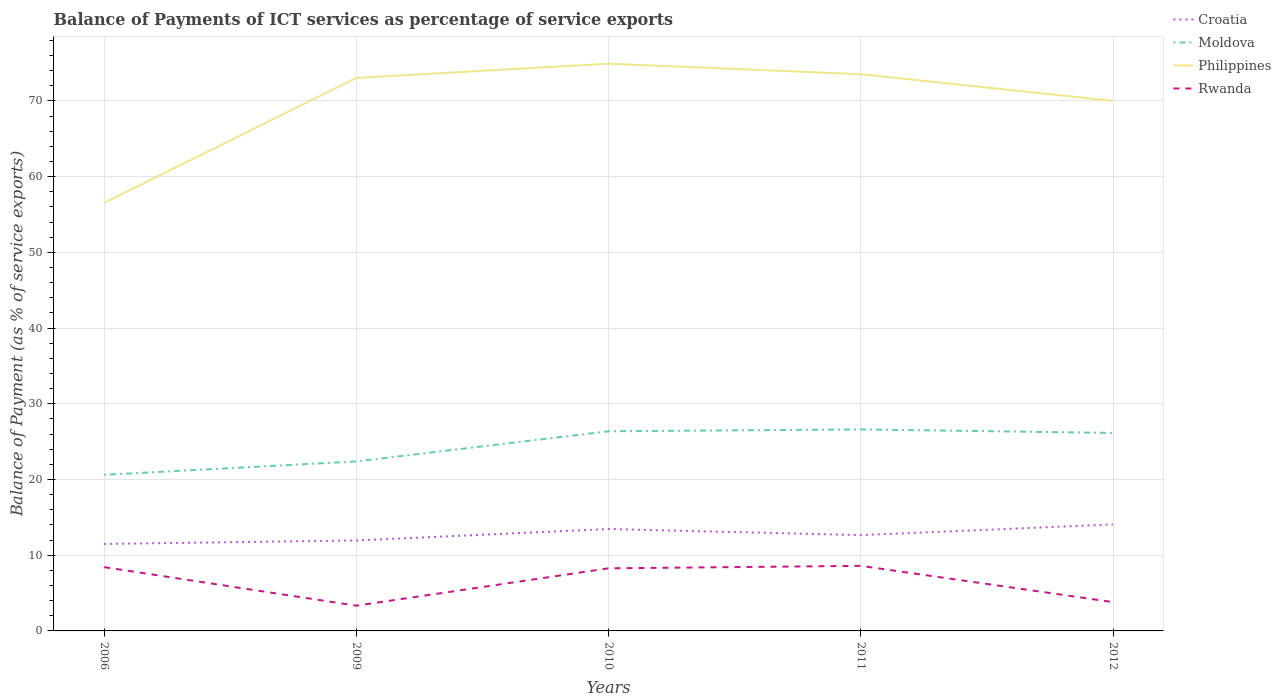Across all years, what is the maximum balance of payments of ICT services in Moldova?
Keep it short and to the point. 20.62. What is the total balance of payments of ICT services in Philippines in the graph?
Give a very brief answer. -18.39. What is the difference between the highest and the second highest balance of payments of ICT services in Croatia?
Give a very brief answer. 2.57. Is the balance of payments of ICT services in Philippines strictly greater than the balance of payments of ICT services in Croatia over the years?
Your response must be concise. No. How many years are there in the graph?
Give a very brief answer. 5. Are the values on the major ticks of Y-axis written in scientific E-notation?
Offer a very short reply. No. Does the graph contain any zero values?
Ensure brevity in your answer.  No. How are the legend labels stacked?
Provide a short and direct response. Vertical. What is the title of the graph?
Your response must be concise. Balance of Payments of ICT services as percentage of service exports. Does "Cote d'Ivoire" appear as one of the legend labels in the graph?
Your answer should be very brief. No. What is the label or title of the Y-axis?
Make the answer very short. Balance of Payment (as % of service exports). What is the Balance of Payment (as % of service exports) of Croatia in 2006?
Offer a terse response. 11.49. What is the Balance of Payment (as % of service exports) of Moldova in 2006?
Your response must be concise. 20.62. What is the Balance of Payment (as % of service exports) of Philippines in 2006?
Your answer should be compact. 56.53. What is the Balance of Payment (as % of service exports) in Rwanda in 2006?
Provide a succinct answer. 8.42. What is the Balance of Payment (as % of service exports) in Croatia in 2009?
Offer a terse response. 11.94. What is the Balance of Payment (as % of service exports) of Moldova in 2009?
Offer a very short reply. 22.39. What is the Balance of Payment (as % of service exports) of Philippines in 2009?
Keep it short and to the point. 73.04. What is the Balance of Payment (as % of service exports) of Rwanda in 2009?
Offer a terse response. 3.33. What is the Balance of Payment (as % of service exports) in Croatia in 2010?
Give a very brief answer. 13.46. What is the Balance of Payment (as % of service exports) of Moldova in 2010?
Provide a short and direct response. 26.37. What is the Balance of Payment (as % of service exports) in Philippines in 2010?
Your answer should be very brief. 74.92. What is the Balance of Payment (as % of service exports) of Rwanda in 2010?
Ensure brevity in your answer.  8.27. What is the Balance of Payment (as % of service exports) of Croatia in 2011?
Give a very brief answer. 12.66. What is the Balance of Payment (as % of service exports) of Moldova in 2011?
Your answer should be very brief. 26.62. What is the Balance of Payment (as % of service exports) in Philippines in 2011?
Provide a short and direct response. 73.53. What is the Balance of Payment (as % of service exports) in Rwanda in 2011?
Make the answer very short. 8.59. What is the Balance of Payment (as % of service exports) in Croatia in 2012?
Your answer should be very brief. 14.06. What is the Balance of Payment (as % of service exports) in Moldova in 2012?
Provide a succinct answer. 26.15. What is the Balance of Payment (as % of service exports) of Philippines in 2012?
Offer a terse response. 70.01. What is the Balance of Payment (as % of service exports) of Rwanda in 2012?
Your answer should be very brief. 3.81. Across all years, what is the maximum Balance of Payment (as % of service exports) in Croatia?
Your answer should be very brief. 14.06. Across all years, what is the maximum Balance of Payment (as % of service exports) in Moldova?
Give a very brief answer. 26.62. Across all years, what is the maximum Balance of Payment (as % of service exports) in Philippines?
Keep it short and to the point. 74.92. Across all years, what is the maximum Balance of Payment (as % of service exports) of Rwanda?
Provide a short and direct response. 8.59. Across all years, what is the minimum Balance of Payment (as % of service exports) in Croatia?
Ensure brevity in your answer.  11.49. Across all years, what is the minimum Balance of Payment (as % of service exports) in Moldova?
Make the answer very short. 20.62. Across all years, what is the minimum Balance of Payment (as % of service exports) of Philippines?
Your answer should be compact. 56.53. Across all years, what is the minimum Balance of Payment (as % of service exports) in Rwanda?
Ensure brevity in your answer.  3.33. What is the total Balance of Payment (as % of service exports) of Croatia in the graph?
Provide a succinct answer. 63.62. What is the total Balance of Payment (as % of service exports) in Moldova in the graph?
Keep it short and to the point. 122.14. What is the total Balance of Payment (as % of service exports) in Philippines in the graph?
Make the answer very short. 348.04. What is the total Balance of Payment (as % of service exports) in Rwanda in the graph?
Offer a very short reply. 32.43. What is the difference between the Balance of Payment (as % of service exports) of Croatia in 2006 and that in 2009?
Provide a short and direct response. -0.45. What is the difference between the Balance of Payment (as % of service exports) of Moldova in 2006 and that in 2009?
Offer a very short reply. -1.77. What is the difference between the Balance of Payment (as % of service exports) of Philippines in 2006 and that in 2009?
Give a very brief answer. -16.51. What is the difference between the Balance of Payment (as % of service exports) in Rwanda in 2006 and that in 2009?
Make the answer very short. 5.09. What is the difference between the Balance of Payment (as % of service exports) of Croatia in 2006 and that in 2010?
Ensure brevity in your answer.  -1.97. What is the difference between the Balance of Payment (as % of service exports) in Moldova in 2006 and that in 2010?
Offer a terse response. -5.75. What is the difference between the Balance of Payment (as % of service exports) in Philippines in 2006 and that in 2010?
Offer a very short reply. -18.39. What is the difference between the Balance of Payment (as % of service exports) in Rwanda in 2006 and that in 2010?
Offer a very short reply. 0.16. What is the difference between the Balance of Payment (as % of service exports) of Croatia in 2006 and that in 2011?
Provide a succinct answer. -1.16. What is the difference between the Balance of Payment (as % of service exports) of Moldova in 2006 and that in 2011?
Your answer should be compact. -6. What is the difference between the Balance of Payment (as % of service exports) of Philippines in 2006 and that in 2011?
Your answer should be very brief. -17. What is the difference between the Balance of Payment (as % of service exports) of Rwanda in 2006 and that in 2011?
Your response must be concise. -0.17. What is the difference between the Balance of Payment (as % of service exports) in Croatia in 2006 and that in 2012?
Your response must be concise. -2.57. What is the difference between the Balance of Payment (as % of service exports) in Moldova in 2006 and that in 2012?
Provide a succinct answer. -5.53. What is the difference between the Balance of Payment (as % of service exports) in Philippines in 2006 and that in 2012?
Your answer should be very brief. -13.47. What is the difference between the Balance of Payment (as % of service exports) of Rwanda in 2006 and that in 2012?
Keep it short and to the point. 4.62. What is the difference between the Balance of Payment (as % of service exports) of Croatia in 2009 and that in 2010?
Provide a succinct answer. -1.52. What is the difference between the Balance of Payment (as % of service exports) in Moldova in 2009 and that in 2010?
Offer a very short reply. -3.98. What is the difference between the Balance of Payment (as % of service exports) in Philippines in 2009 and that in 2010?
Offer a very short reply. -1.88. What is the difference between the Balance of Payment (as % of service exports) of Rwanda in 2009 and that in 2010?
Offer a terse response. -4.93. What is the difference between the Balance of Payment (as % of service exports) of Croatia in 2009 and that in 2011?
Your answer should be very brief. -0.71. What is the difference between the Balance of Payment (as % of service exports) of Moldova in 2009 and that in 2011?
Provide a succinct answer. -4.23. What is the difference between the Balance of Payment (as % of service exports) of Philippines in 2009 and that in 2011?
Provide a short and direct response. -0.49. What is the difference between the Balance of Payment (as % of service exports) in Rwanda in 2009 and that in 2011?
Your answer should be compact. -5.26. What is the difference between the Balance of Payment (as % of service exports) in Croatia in 2009 and that in 2012?
Your answer should be compact. -2.12. What is the difference between the Balance of Payment (as % of service exports) of Moldova in 2009 and that in 2012?
Your response must be concise. -3.76. What is the difference between the Balance of Payment (as % of service exports) in Philippines in 2009 and that in 2012?
Provide a succinct answer. 3.03. What is the difference between the Balance of Payment (as % of service exports) in Rwanda in 2009 and that in 2012?
Offer a very short reply. -0.47. What is the difference between the Balance of Payment (as % of service exports) of Croatia in 2010 and that in 2011?
Provide a succinct answer. 0.81. What is the difference between the Balance of Payment (as % of service exports) in Moldova in 2010 and that in 2011?
Offer a very short reply. -0.25. What is the difference between the Balance of Payment (as % of service exports) of Philippines in 2010 and that in 2011?
Offer a very short reply. 1.39. What is the difference between the Balance of Payment (as % of service exports) of Rwanda in 2010 and that in 2011?
Provide a succinct answer. -0.33. What is the difference between the Balance of Payment (as % of service exports) of Croatia in 2010 and that in 2012?
Make the answer very short. -0.6. What is the difference between the Balance of Payment (as % of service exports) in Moldova in 2010 and that in 2012?
Offer a terse response. 0.22. What is the difference between the Balance of Payment (as % of service exports) in Philippines in 2010 and that in 2012?
Your answer should be very brief. 4.92. What is the difference between the Balance of Payment (as % of service exports) in Rwanda in 2010 and that in 2012?
Provide a short and direct response. 4.46. What is the difference between the Balance of Payment (as % of service exports) in Croatia in 2011 and that in 2012?
Give a very brief answer. -1.41. What is the difference between the Balance of Payment (as % of service exports) in Moldova in 2011 and that in 2012?
Ensure brevity in your answer.  0.47. What is the difference between the Balance of Payment (as % of service exports) in Philippines in 2011 and that in 2012?
Give a very brief answer. 3.53. What is the difference between the Balance of Payment (as % of service exports) in Rwanda in 2011 and that in 2012?
Your response must be concise. 4.79. What is the difference between the Balance of Payment (as % of service exports) in Croatia in 2006 and the Balance of Payment (as % of service exports) in Moldova in 2009?
Offer a terse response. -10.9. What is the difference between the Balance of Payment (as % of service exports) in Croatia in 2006 and the Balance of Payment (as % of service exports) in Philippines in 2009?
Provide a short and direct response. -61.55. What is the difference between the Balance of Payment (as % of service exports) of Croatia in 2006 and the Balance of Payment (as % of service exports) of Rwanda in 2009?
Give a very brief answer. 8.16. What is the difference between the Balance of Payment (as % of service exports) of Moldova in 2006 and the Balance of Payment (as % of service exports) of Philippines in 2009?
Ensure brevity in your answer.  -52.42. What is the difference between the Balance of Payment (as % of service exports) in Moldova in 2006 and the Balance of Payment (as % of service exports) in Rwanda in 2009?
Provide a short and direct response. 17.28. What is the difference between the Balance of Payment (as % of service exports) of Philippines in 2006 and the Balance of Payment (as % of service exports) of Rwanda in 2009?
Offer a terse response. 53.2. What is the difference between the Balance of Payment (as % of service exports) in Croatia in 2006 and the Balance of Payment (as % of service exports) in Moldova in 2010?
Keep it short and to the point. -14.88. What is the difference between the Balance of Payment (as % of service exports) of Croatia in 2006 and the Balance of Payment (as % of service exports) of Philippines in 2010?
Provide a short and direct response. -63.43. What is the difference between the Balance of Payment (as % of service exports) of Croatia in 2006 and the Balance of Payment (as % of service exports) of Rwanda in 2010?
Keep it short and to the point. 3.22. What is the difference between the Balance of Payment (as % of service exports) of Moldova in 2006 and the Balance of Payment (as % of service exports) of Philippines in 2010?
Your answer should be very brief. -54.3. What is the difference between the Balance of Payment (as % of service exports) of Moldova in 2006 and the Balance of Payment (as % of service exports) of Rwanda in 2010?
Provide a short and direct response. 12.35. What is the difference between the Balance of Payment (as % of service exports) in Philippines in 2006 and the Balance of Payment (as % of service exports) in Rwanda in 2010?
Your answer should be very brief. 48.27. What is the difference between the Balance of Payment (as % of service exports) of Croatia in 2006 and the Balance of Payment (as % of service exports) of Moldova in 2011?
Ensure brevity in your answer.  -15.13. What is the difference between the Balance of Payment (as % of service exports) in Croatia in 2006 and the Balance of Payment (as % of service exports) in Philippines in 2011?
Ensure brevity in your answer.  -62.04. What is the difference between the Balance of Payment (as % of service exports) of Croatia in 2006 and the Balance of Payment (as % of service exports) of Rwanda in 2011?
Your answer should be compact. 2.9. What is the difference between the Balance of Payment (as % of service exports) of Moldova in 2006 and the Balance of Payment (as % of service exports) of Philippines in 2011?
Offer a very short reply. -52.91. What is the difference between the Balance of Payment (as % of service exports) of Moldova in 2006 and the Balance of Payment (as % of service exports) of Rwanda in 2011?
Offer a very short reply. 12.02. What is the difference between the Balance of Payment (as % of service exports) in Philippines in 2006 and the Balance of Payment (as % of service exports) in Rwanda in 2011?
Your answer should be compact. 47.94. What is the difference between the Balance of Payment (as % of service exports) in Croatia in 2006 and the Balance of Payment (as % of service exports) in Moldova in 2012?
Make the answer very short. -14.66. What is the difference between the Balance of Payment (as % of service exports) of Croatia in 2006 and the Balance of Payment (as % of service exports) of Philippines in 2012?
Keep it short and to the point. -58.52. What is the difference between the Balance of Payment (as % of service exports) of Croatia in 2006 and the Balance of Payment (as % of service exports) of Rwanda in 2012?
Give a very brief answer. 7.68. What is the difference between the Balance of Payment (as % of service exports) of Moldova in 2006 and the Balance of Payment (as % of service exports) of Philippines in 2012?
Ensure brevity in your answer.  -49.39. What is the difference between the Balance of Payment (as % of service exports) in Moldova in 2006 and the Balance of Payment (as % of service exports) in Rwanda in 2012?
Offer a very short reply. 16.81. What is the difference between the Balance of Payment (as % of service exports) in Philippines in 2006 and the Balance of Payment (as % of service exports) in Rwanda in 2012?
Make the answer very short. 52.73. What is the difference between the Balance of Payment (as % of service exports) of Croatia in 2009 and the Balance of Payment (as % of service exports) of Moldova in 2010?
Make the answer very short. -14.42. What is the difference between the Balance of Payment (as % of service exports) in Croatia in 2009 and the Balance of Payment (as % of service exports) in Philippines in 2010?
Provide a succinct answer. -62.98. What is the difference between the Balance of Payment (as % of service exports) of Croatia in 2009 and the Balance of Payment (as % of service exports) of Rwanda in 2010?
Provide a succinct answer. 3.68. What is the difference between the Balance of Payment (as % of service exports) in Moldova in 2009 and the Balance of Payment (as % of service exports) in Philippines in 2010?
Offer a very short reply. -52.53. What is the difference between the Balance of Payment (as % of service exports) of Moldova in 2009 and the Balance of Payment (as % of service exports) of Rwanda in 2010?
Provide a succinct answer. 14.12. What is the difference between the Balance of Payment (as % of service exports) in Philippines in 2009 and the Balance of Payment (as % of service exports) in Rwanda in 2010?
Your answer should be very brief. 64.77. What is the difference between the Balance of Payment (as % of service exports) of Croatia in 2009 and the Balance of Payment (as % of service exports) of Moldova in 2011?
Make the answer very short. -14.67. What is the difference between the Balance of Payment (as % of service exports) of Croatia in 2009 and the Balance of Payment (as % of service exports) of Philippines in 2011?
Give a very brief answer. -61.59. What is the difference between the Balance of Payment (as % of service exports) of Croatia in 2009 and the Balance of Payment (as % of service exports) of Rwanda in 2011?
Keep it short and to the point. 3.35. What is the difference between the Balance of Payment (as % of service exports) in Moldova in 2009 and the Balance of Payment (as % of service exports) in Philippines in 2011?
Give a very brief answer. -51.14. What is the difference between the Balance of Payment (as % of service exports) in Moldova in 2009 and the Balance of Payment (as % of service exports) in Rwanda in 2011?
Make the answer very short. 13.8. What is the difference between the Balance of Payment (as % of service exports) of Philippines in 2009 and the Balance of Payment (as % of service exports) of Rwanda in 2011?
Make the answer very short. 64.45. What is the difference between the Balance of Payment (as % of service exports) of Croatia in 2009 and the Balance of Payment (as % of service exports) of Moldova in 2012?
Your answer should be very brief. -14.21. What is the difference between the Balance of Payment (as % of service exports) in Croatia in 2009 and the Balance of Payment (as % of service exports) in Philippines in 2012?
Your answer should be compact. -58.06. What is the difference between the Balance of Payment (as % of service exports) of Croatia in 2009 and the Balance of Payment (as % of service exports) of Rwanda in 2012?
Give a very brief answer. 8.14. What is the difference between the Balance of Payment (as % of service exports) of Moldova in 2009 and the Balance of Payment (as % of service exports) of Philippines in 2012?
Offer a terse response. -47.62. What is the difference between the Balance of Payment (as % of service exports) in Moldova in 2009 and the Balance of Payment (as % of service exports) in Rwanda in 2012?
Your response must be concise. 18.58. What is the difference between the Balance of Payment (as % of service exports) in Philippines in 2009 and the Balance of Payment (as % of service exports) in Rwanda in 2012?
Provide a short and direct response. 69.23. What is the difference between the Balance of Payment (as % of service exports) in Croatia in 2010 and the Balance of Payment (as % of service exports) in Moldova in 2011?
Provide a short and direct response. -13.16. What is the difference between the Balance of Payment (as % of service exports) of Croatia in 2010 and the Balance of Payment (as % of service exports) of Philippines in 2011?
Your response must be concise. -60.07. What is the difference between the Balance of Payment (as % of service exports) of Croatia in 2010 and the Balance of Payment (as % of service exports) of Rwanda in 2011?
Provide a succinct answer. 4.87. What is the difference between the Balance of Payment (as % of service exports) of Moldova in 2010 and the Balance of Payment (as % of service exports) of Philippines in 2011?
Your answer should be very brief. -47.17. What is the difference between the Balance of Payment (as % of service exports) of Moldova in 2010 and the Balance of Payment (as % of service exports) of Rwanda in 2011?
Make the answer very short. 17.77. What is the difference between the Balance of Payment (as % of service exports) of Philippines in 2010 and the Balance of Payment (as % of service exports) of Rwanda in 2011?
Your answer should be compact. 66.33. What is the difference between the Balance of Payment (as % of service exports) of Croatia in 2010 and the Balance of Payment (as % of service exports) of Moldova in 2012?
Give a very brief answer. -12.69. What is the difference between the Balance of Payment (as % of service exports) of Croatia in 2010 and the Balance of Payment (as % of service exports) of Philippines in 2012?
Offer a very short reply. -56.54. What is the difference between the Balance of Payment (as % of service exports) in Croatia in 2010 and the Balance of Payment (as % of service exports) in Rwanda in 2012?
Keep it short and to the point. 9.65. What is the difference between the Balance of Payment (as % of service exports) in Moldova in 2010 and the Balance of Payment (as % of service exports) in Philippines in 2012?
Offer a terse response. -43.64. What is the difference between the Balance of Payment (as % of service exports) of Moldova in 2010 and the Balance of Payment (as % of service exports) of Rwanda in 2012?
Give a very brief answer. 22.56. What is the difference between the Balance of Payment (as % of service exports) in Philippines in 2010 and the Balance of Payment (as % of service exports) in Rwanda in 2012?
Your answer should be very brief. 71.11. What is the difference between the Balance of Payment (as % of service exports) in Croatia in 2011 and the Balance of Payment (as % of service exports) in Moldova in 2012?
Offer a very short reply. -13.5. What is the difference between the Balance of Payment (as % of service exports) in Croatia in 2011 and the Balance of Payment (as % of service exports) in Philippines in 2012?
Provide a short and direct response. -57.35. What is the difference between the Balance of Payment (as % of service exports) of Croatia in 2011 and the Balance of Payment (as % of service exports) of Rwanda in 2012?
Offer a terse response. 8.85. What is the difference between the Balance of Payment (as % of service exports) of Moldova in 2011 and the Balance of Payment (as % of service exports) of Philippines in 2012?
Offer a very short reply. -43.39. What is the difference between the Balance of Payment (as % of service exports) of Moldova in 2011 and the Balance of Payment (as % of service exports) of Rwanda in 2012?
Your answer should be very brief. 22.81. What is the difference between the Balance of Payment (as % of service exports) in Philippines in 2011 and the Balance of Payment (as % of service exports) in Rwanda in 2012?
Give a very brief answer. 69.72. What is the average Balance of Payment (as % of service exports) in Croatia per year?
Provide a succinct answer. 12.72. What is the average Balance of Payment (as % of service exports) of Moldova per year?
Your answer should be compact. 24.43. What is the average Balance of Payment (as % of service exports) of Philippines per year?
Offer a terse response. 69.61. What is the average Balance of Payment (as % of service exports) in Rwanda per year?
Ensure brevity in your answer.  6.49. In the year 2006, what is the difference between the Balance of Payment (as % of service exports) of Croatia and Balance of Payment (as % of service exports) of Moldova?
Your answer should be very brief. -9.13. In the year 2006, what is the difference between the Balance of Payment (as % of service exports) of Croatia and Balance of Payment (as % of service exports) of Philippines?
Your response must be concise. -45.04. In the year 2006, what is the difference between the Balance of Payment (as % of service exports) of Croatia and Balance of Payment (as % of service exports) of Rwanda?
Provide a succinct answer. 3.07. In the year 2006, what is the difference between the Balance of Payment (as % of service exports) in Moldova and Balance of Payment (as % of service exports) in Philippines?
Ensure brevity in your answer.  -35.92. In the year 2006, what is the difference between the Balance of Payment (as % of service exports) in Moldova and Balance of Payment (as % of service exports) in Rwanda?
Keep it short and to the point. 12.19. In the year 2006, what is the difference between the Balance of Payment (as % of service exports) in Philippines and Balance of Payment (as % of service exports) in Rwanda?
Make the answer very short. 48.11. In the year 2009, what is the difference between the Balance of Payment (as % of service exports) of Croatia and Balance of Payment (as % of service exports) of Moldova?
Give a very brief answer. -10.45. In the year 2009, what is the difference between the Balance of Payment (as % of service exports) in Croatia and Balance of Payment (as % of service exports) in Philippines?
Your answer should be compact. -61.1. In the year 2009, what is the difference between the Balance of Payment (as % of service exports) of Croatia and Balance of Payment (as % of service exports) of Rwanda?
Keep it short and to the point. 8.61. In the year 2009, what is the difference between the Balance of Payment (as % of service exports) in Moldova and Balance of Payment (as % of service exports) in Philippines?
Your answer should be compact. -50.65. In the year 2009, what is the difference between the Balance of Payment (as % of service exports) in Moldova and Balance of Payment (as % of service exports) in Rwanda?
Make the answer very short. 19.06. In the year 2009, what is the difference between the Balance of Payment (as % of service exports) of Philippines and Balance of Payment (as % of service exports) of Rwanda?
Give a very brief answer. 69.71. In the year 2010, what is the difference between the Balance of Payment (as % of service exports) in Croatia and Balance of Payment (as % of service exports) in Moldova?
Keep it short and to the point. -12.91. In the year 2010, what is the difference between the Balance of Payment (as % of service exports) in Croatia and Balance of Payment (as % of service exports) in Philippines?
Provide a short and direct response. -61.46. In the year 2010, what is the difference between the Balance of Payment (as % of service exports) of Croatia and Balance of Payment (as % of service exports) of Rwanda?
Offer a very short reply. 5.19. In the year 2010, what is the difference between the Balance of Payment (as % of service exports) of Moldova and Balance of Payment (as % of service exports) of Philippines?
Provide a succinct answer. -48.55. In the year 2010, what is the difference between the Balance of Payment (as % of service exports) in Moldova and Balance of Payment (as % of service exports) in Rwanda?
Provide a short and direct response. 18.1. In the year 2010, what is the difference between the Balance of Payment (as % of service exports) of Philippines and Balance of Payment (as % of service exports) of Rwanda?
Make the answer very short. 66.65. In the year 2011, what is the difference between the Balance of Payment (as % of service exports) of Croatia and Balance of Payment (as % of service exports) of Moldova?
Give a very brief answer. -13.96. In the year 2011, what is the difference between the Balance of Payment (as % of service exports) of Croatia and Balance of Payment (as % of service exports) of Philippines?
Your response must be concise. -60.88. In the year 2011, what is the difference between the Balance of Payment (as % of service exports) of Croatia and Balance of Payment (as % of service exports) of Rwanda?
Offer a very short reply. 4.06. In the year 2011, what is the difference between the Balance of Payment (as % of service exports) of Moldova and Balance of Payment (as % of service exports) of Philippines?
Provide a short and direct response. -46.92. In the year 2011, what is the difference between the Balance of Payment (as % of service exports) of Moldova and Balance of Payment (as % of service exports) of Rwanda?
Give a very brief answer. 18.02. In the year 2011, what is the difference between the Balance of Payment (as % of service exports) in Philippines and Balance of Payment (as % of service exports) in Rwanda?
Make the answer very short. 64.94. In the year 2012, what is the difference between the Balance of Payment (as % of service exports) of Croatia and Balance of Payment (as % of service exports) of Moldova?
Provide a succinct answer. -12.09. In the year 2012, what is the difference between the Balance of Payment (as % of service exports) in Croatia and Balance of Payment (as % of service exports) in Philippines?
Your answer should be very brief. -55.94. In the year 2012, what is the difference between the Balance of Payment (as % of service exports) in Croatia and Balance of Payment (as % of service exports) in Rwanda?
Provide a short and direct response. 10.26. In the year 2012, what is the difference between the Balance of Payment (as % of service exports) of Moldova and Balance of Payment (as % of service exports) of Philippines?
Provide a short and direct response. -43.86. In the year 2012, what is the difference between the Balance of Payment (as % of service exports) of Moldova and Balance of Payment (as % of service exports) of Rwanda?
Your response must be concise. 22.34. In the year 2012, what is the difference between the Balance of Payment (as % of service exports) of Philippines and Balance of Payment (as % of service exports) of Rwanda?
Provide a short and direct response. 66.2. What is the ratio of the Balance of Payment (as % of service exports) of Croatia in 2006 to that in 2009?
Provide a short and direct response. 0.96. What is the ratio of the Balance of Payment (as % of service exports) of Moldova in 2006 to that in 2009?
Give a very brief answer. 0.92. What is the ratio of the Balance of Payment (as % of service exports) of Philippines in 2006 to that in 2009?
Make the answer very short. 0.77. What is the ratio of the Balance of Payment (as % of service exports) of Rwanda in 2006 to that in 2009?
Provide a succinct answer. 2.53. What is the ratio of the Balance of Payment (as % of service exports) of Croatia in 2006 to that in 2010?
Keep it short and to the point. 0.85. What is the ratio of the Balance of Payment (as % of service exports) of Moldova in 2006 to that in 2010?
Keep it short and to the point. 0.78. What is the ratio of the Balance of Payment (as % of service exports) in Philippines in 2006 to that in 2010?
Give a very brief answer. 0.75. What is the ratio of the Balance of Payment (as % of service exports) of Rwanda in 2006 to that in 2010?
Provide a succinct answer. 1.02. What is the ratio of the Balance of Payment (as % of service exports) of Croatia in 2006 to that in 2011?
Provide a succinct answer. 0.91. What is the ratio of the Balance of Payment (as % of service exports) in Moldova in 2006 to that in 2011?
Offer a terse response. 0.77. What is the ratio of the Balance of Payment (as % of service exports) of Philippines in 2006 to that in 2011?
Keep it short and to the point. 0.77. What is the ratio of the Balance of Payment (as % of service exports) in Rwanda in 2006 to that in 2011?
Your answer should be compact. 0.98. What is the ratio of the Balance of Payment (as % of service exports) in Croatia in 2006 to that in 2012?
Provide a succinct answer. 0.82. What is the ratio of the Balance of Payment (as % of service exports) in Moldova in 2006 to that in 2012?
Your answer should be compact. 0.79. What is the ratio of the Balance of Payment (as % of service exports) in Philippines in 2006 to that in 2012?
Provide a short and direct response. 0.81. What is the ratio of the Balance of Payment (as % of service exports) in Rwanda in 2006 to that in 2012?
Provide a short and direct response. 2.21. What is the ratio of the Balance of Payment (as % of service exports) in Croatia in 2009 to that in 2010?
Ensure brevity in your answer.  0.89. What is the ratio of the Balance of Payment (as % of service exports) of Moldova in 2009 to that in 2010?
Your answer should be very brief. 0.85. What is the ratio of the Balance of Payment (as % of service exports) of Philippines in 2009 to that in 2010?
Offer a terse response. 0.97. What is the ratio of the Balance of Payment (as % of service exports) of Rwanda in 2009 to that in 2010?
Provide a succinct answer. 0.4. What is the ratio of the Balance of Payment (as % of service exports) in Croatia in 2009 to that in 2011?
Your response must be concise. 0.94. What is the ratio of the Balance of Payment (as % of service exports) of Moldova in 2009 to that in 2011?
Provide a short and direct response. 0.84. What is the ratio of the Balance of Payment (as % of service exports) in Rwanda in 2009 to that in 2011?
Ensure brevity in your answer.  0.39. What is the ratio of the Balance of Payment (as % of service exports) of Croatia in 2009 to that in 2012?
Provide a short and direct response. 0.85. What is the ratio of the Balance of Payment (as % of service exports) of Moldova in 2009 to that in 2012?
Provide a succinct answer. 0.86. What is the ratio of the Balance of Payment (as % of service exports) in Philippines in 2009 to that in 2012?
Keep it short and to the point. 1.04. What is the ratio of the Balance of Payment (as % of service exports) of Rwanda in 2009 to that in 2012?
Ensure brevity in your answer.  0.88. What is the ratio of the Balance of Payment (as % of service exports) in Croatia in 2010 to that in 2011?
Your response must be concise. 1.06. What is the ratio of the Balance of Payment (as % of service exports) in Moldova in 2010 to that in 2011?
Your response must be concise. 0.99. What is the ratio of the Balance of Payment (as % of service exports) of Philippines in 2010 to that in 2011?
Make the answer very short. 1.02. What is the ratio of the Balance of Payment (as % of service exports) in Rwanda in 2010 to that in 2011?
Offer a terse response. 0.96. What is the ratio of the Balance of Payment (as % of service exports) of Croatia in 2010 to that in 2012?
Your answer should be compact. 0.96. What is the ratio of the Balance of Payment (as % of service exports) of Moldova in 2010 to that in 2012?
Your response must be concise. 1.01. What is the ratio of the Balance of Payment (as % of service exports) in Philippines in 2010 to that in 2012?
Offer a terse response. 1.07. What is the ratio of the Balance of Payment (as % of service exports) of Rwanda in 2010 to that in 2012?
Your answer should be very brief. 2.17. What is the ratio of the Balance of Payment (as % of service exports) in Croatia in 2011 to that in 2012?
Offer a terse response. 0.9. What is the ratio of the Balance of Payment (as % of service exports) of Moldova in 2011 to that in 2012?
Give a very brief answer. 1.02. What is the ratio of the Balance of Payment (as % of service exports) in Philippines in 2011 to that in 2012?
Your answer should be compact. 1.05. What is the ratio of the Balance of Payment (as % of service exports) of Rwanda in 2011 to that in 2012?
Provide a succinct answer. 2.26. What is the difference between the highest and the second highest Balance of Payment (as % of service exports) in Croatia?
Keep it short and to the point. 0.6. What is the difference between the highest and the second highest Balance of Payment (as % of service exports) of Moldova?
Offer a terse response. 0.25. What is the difference between the highest and the second highest Balance of Payment (as % of service exports) of Philippines?
Your response must be concise. 1.39. What is the difference between the highest and the second highest Balance of Payment (as % of service exports) of Rwanda?
Provide a short and direct response. 0.17. What is the difference between the highest and the lowest Balance of Payment (as % of service exports) in Croatia?
Ensure brevity in your answer.  2.57. What is the difference between the highest and the lowest Balance of Payment (as % of service exports) in Moldova?
Give a very brief answer. 6. What is the difference between the highest and the lowest Balance of Payment (as % of service exports) in Philippines?
Keep it short and to the point. 18.39. What is the difference between the highest and the lowest Balance of Payment (as % of service exports) in Rwanda?
Keep it short and to the point. 5.26. 